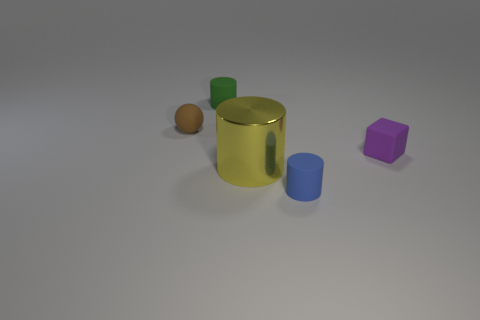Is there anything else that is the same material as the large yellow cylinder?
Ensure brevity in your answer.  No. What material is the cylinder on the left side of the big yellow thing?
Keep it short and to the point. Rubber. Are there more big yellow shiny things on the right side of the metallic object than small brown spheres?
Your answer should be very brief. No. There is a small blue rubber thing that is in front of the small rubber cylinder to the left of the tiny blue matte object; is there a yellow cylinder that is in front of it?
Give a very brief answer. No. There is a green object; are there any green cylinders left of it?
Ensure brevity in your answer.  No. What number of matte things have the same color as the cube?
Your answer should be very brief. 0. What size is the brown sphere that is made of the same material as the tiny purple cube?
Keep it short and to the point. Small. There is a matte object to the right of the small cylinder right of the small green rubber thing to the right of the tiny brown thing; what size is it?
Offer a terse response. Small. There is a rubber cylinder that is in front of the tiny brown rubber ball; what size is it?
Ensure brevity in your answer.  Small. What number of gray objects are tiny matte things or blocks?
Your answer should be very brief. 0. 